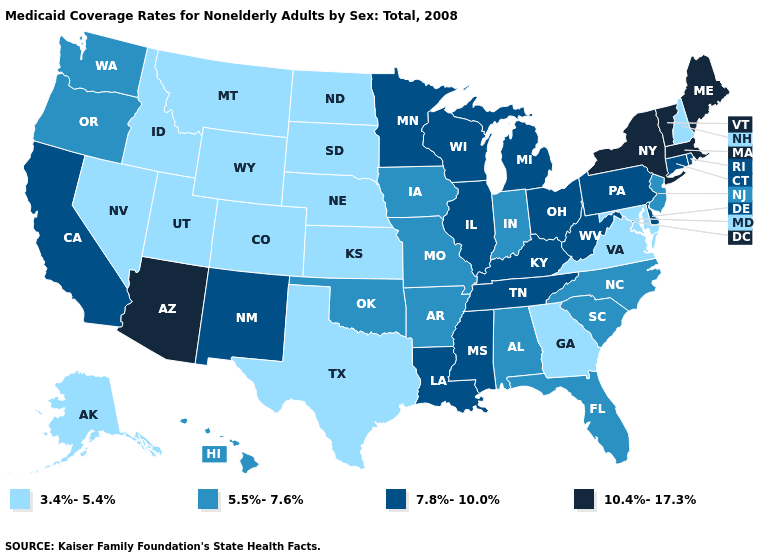What is the highest value in the USA?
Answer briefly. 10.4%-17.3%. Which states have the highest value in the USA?
Short answer required. Arizona, Maine, Massachusetts, New York, Vermont. Does the first symbol in the legend represent the smallest category?
Write a very short answer. Yes. Which states have the lowest value in the MidWest?
Write a very short answer. Kansas, Nebraska, North Dakota, South Dakota. Name the states that have a value in the range 10.4%-17.3%?
Give a very brief answer. Arizona, Maine, Massachusetts, New York, Vermont. Does New Mexico have the same value as Kansas?
Write a very short answer. No. What is the value of Maine?
Give a very brief answer. 10.4%-17.3%. Name the states that have a value in the range 10.4%-17.3%?
Answer briefly. Arizona, Maine, Massachusetts, New York, Vermont. What is the lowest value in the USA?
Give a very brief answer. 3.4%-5.4%. Which states have the highest value in the USA?
Concise answer only. Arizona, Maine, Massachusetts, New York, Vermont. What is the value of Montana?
Be succinct. 3.4%-5.4%. What is the value of Virginia?
Concise answer only. 3.4%-5.4%. Does Colorado have the highest value in the USA?
Give a very brief answer. No. Does Arizona have the highest value in the West?
Keep it brief. Yes. Does Montana have the highest value in the USA?
Concise answer only. No. 